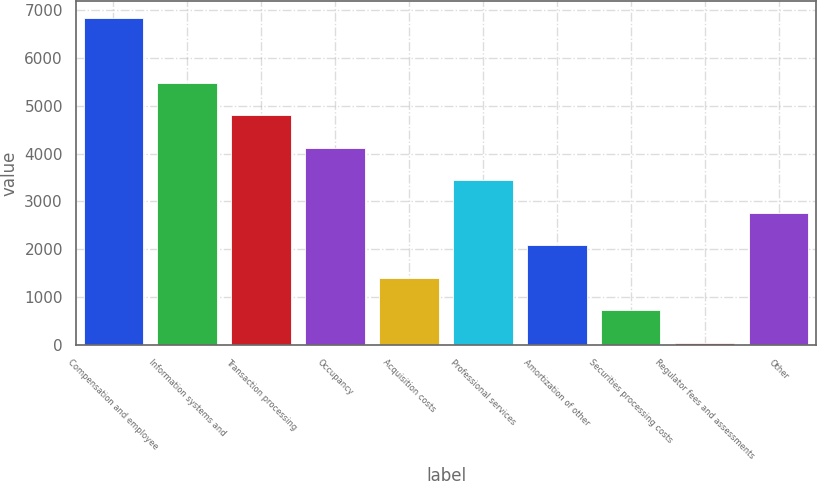<chart> <loc_0><loc_0><loc_500><loc_500><bar_chart><fcel>Compensation and employee<fcel>Information systems and<fcel>Transaction processing<fcel>Occupancy<fcel>Acquisition costs<fcel>Professional services<fcel>Amortization of other<fcel>Securities processing costs<fcel>Regulator fees and assessments<fcel>Other<nl><fcel>6842<fcel>5482.6<fcel>4802.9<fcel>4123.2<fcel>1404.4<fcel>3443.5<fcel>2084.1<fcel>724.7<fcel>45<fcel>2763.8<nl></chart> 